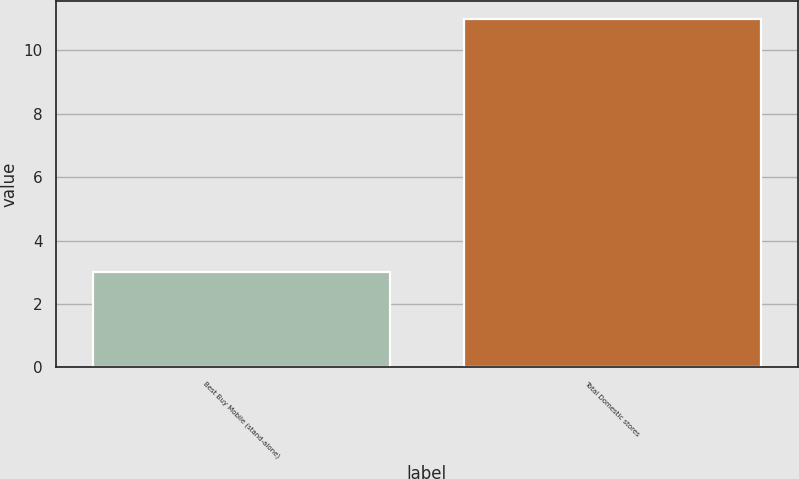<chart> <loc_0><loc_0><loc_500><loc_500><bar_chart><fcel>Best Buy Mobile (stand-alone)<fcel>Total Domestic stores<nl><fcel>3<fcel>11<nl></chart> 